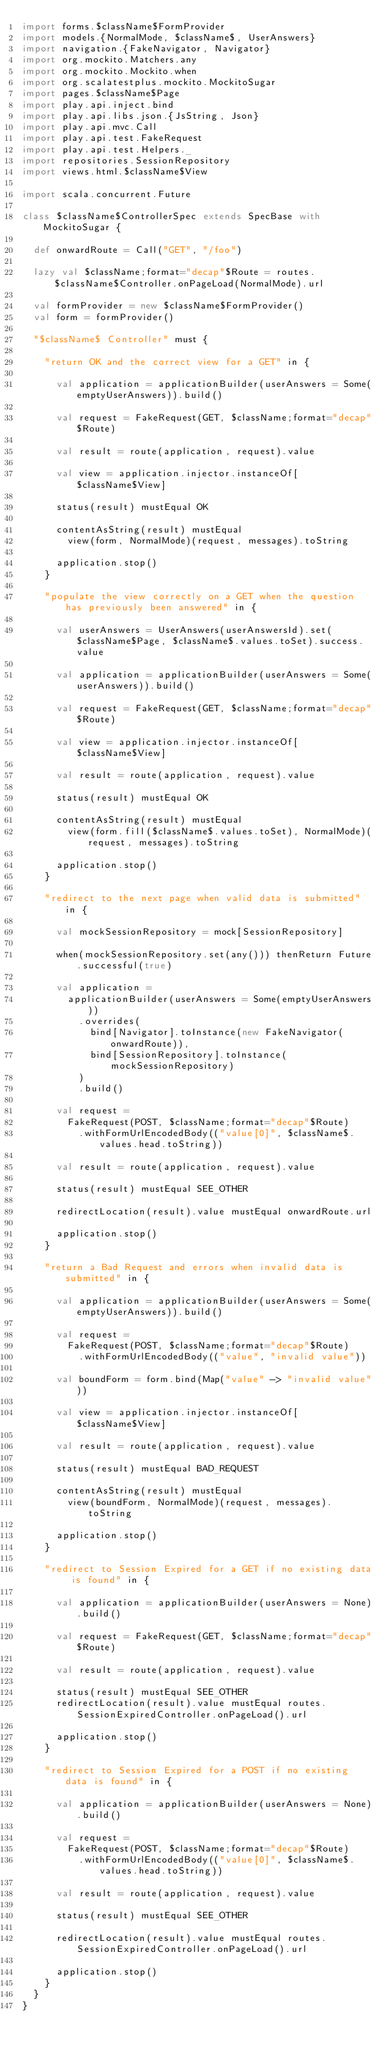Convert code to text. <code><loc_0><loc_0><loc_500><loc_500><_Scala_>import forms.$className$FormProvider
import models.{NormalMode, $className$, UserAnswers}
import navigation.{FakeNavigator, Navigator}
import org.mockito.Matchers.any
import org.mockito.Mockito.when
import org.scalatestplus.mockito.MockitoSugar
import pages.$className$Page
import play.api.inject.bind
import play.api.libs.json.{JsString, Json}
import play.api.mvc.Call
import play.api.test.FakeRequest
import play.api.test.Helpers._
import repositories.SessionRepository
import views.html.$className$View

import scala.concurrent.Future

class $className$ControllerSpec extends SpecBase with MockitoSugar {

  def onwardRoute = Call("GET", "/foo")

  lazy val $className;format="decap"$Route = routes.$className$Controller.onPageLoad(NormalMode).url

  val formProvider = new $className$FormProvider()
  val form = formProvider()

  "$className$ Controller" must {

    "return OK and the correct view for a GET" in {

      val application = applicationBuilder(userAnswers = Some(emptyUserAnswers)).build()

      val request = FakeRequest(GET, $className;format="decap"$Route)

      val result = route(application, request).value

      val view = application.injector.instanceOf[$className$View]

      status(result) mustEqual OK

      contentAsString(result) mustEqual
        view(form, NormalMode)(request, messages).toString

      application.stop()
    }

    "populate the view correctly on a GET when the question has previously been answered" in {

      val userAnswers = UserAnswers(userAnswersId).set($className$Page, $className$.values.toSet).success.value

      val application = applicationBuilder(userAnswers = Some(userAnswers)).build()

      val request = FakeRequest(GET, $className;format="decap"$Route)

      val view = application.injector.instanceOf[$className$View]

      val result = route(application, request).value

      status(result) mustEqual OK

      contentAsString(result) mustEqual
        view(form.fill($className$.values.toSet), NormalMode)(request, messages).toString

      application.stop()
    }

    "redirect to the next page when valid data is submitted" in {

      val mockSessionRepository = mock[SessionRepository]

      when(mockSessionRepository.set(any())) thenReturn Future.successful(true)

      val application =
        applicationBuilder(userAnswers = Some(emptyUserAnswers))
          .overrides(
            bind[Navigator].toInstance(new FakeNavigator(onwardRoute)),
            bind[SessionRepository].toInstance(mockSessionRepository)
          )
          .build()

      val request =
        FakeRequest(POST, $className;format="decap"$Route)
          .withFormUrlEncodedBody(("value[0]", $className$.values.head.toString))

      val result = route(application, request).value

      status(result) mustEqual SEE_OTHER

      redirectLocation(result).value mustEqual onwardRoute.url

      application.stop()
    }

    "return a Bad Request and errors when invalid data is submitted" in {

      val application = applicationBuilder(userAnswers = Some(emptyUserAnswers)).build()

      val request =
        FakeRequest(POST, $className;format="decap"$Route)
          .withFormUrlEncodedBody(("value", "invalid value"))

      val boundForm = form.bind(Map("value" -> "invalid value"))

      val view = application.injector.instanceOf[$className$View]

      val result = route(application, request).value

      status(result) mustEqual BAD_REQUEST

      contentAsString(result) mustEqual
        view(boundForm, NormalMode)(request, messages).toString

      application.stop()
    }

    "redirect to Session Expired for a GET if no existing data is found" in {

      val application = applicationBuilder(userAnswers = None).build()

      val request = FakeRequest(GET, $className;format="decap"$Route)

      val result = route(application, request).value

      status(result) mustEqual SEE_OTHER
      redirectLocation(result).value mustEqual routes.SessionExpiredController.onPageLoad().url

      application.stop()
    }

    "redirect to Session Expired for a POST if no existing data is found" in {
      
      val application = applicationBuilder(userAnswers = None).build()

      val request =
        FakeRequest(POST, $className;format="decap"$Route)
          .withFormUrlEncodedBody(("value[0]", $className$.values.head.toString))

      val result = route(application, request).value

      status(result) mustEqual SEE_OTHER

      redirectLocation(result).value mustEqual routes.SessionExpiredController.onPageLoad().url

      application.stop()
    }
  }
}
</code> 